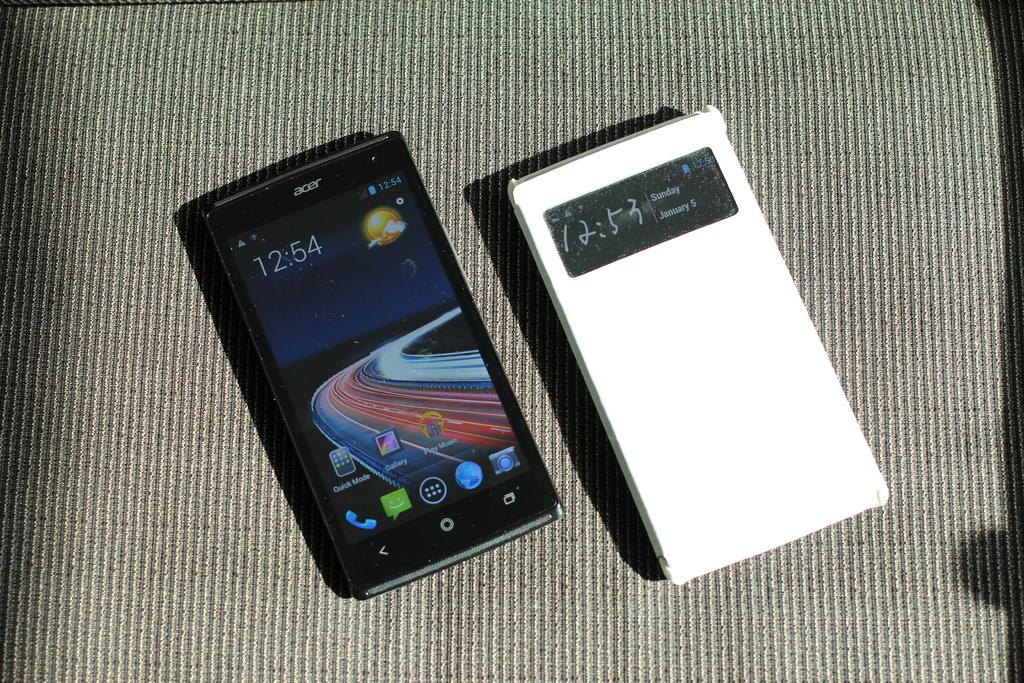What time does it say on the phone?
Keep it short and to the point. 12:54. What brand is this phone?
Your answer should be compact. Acer. 